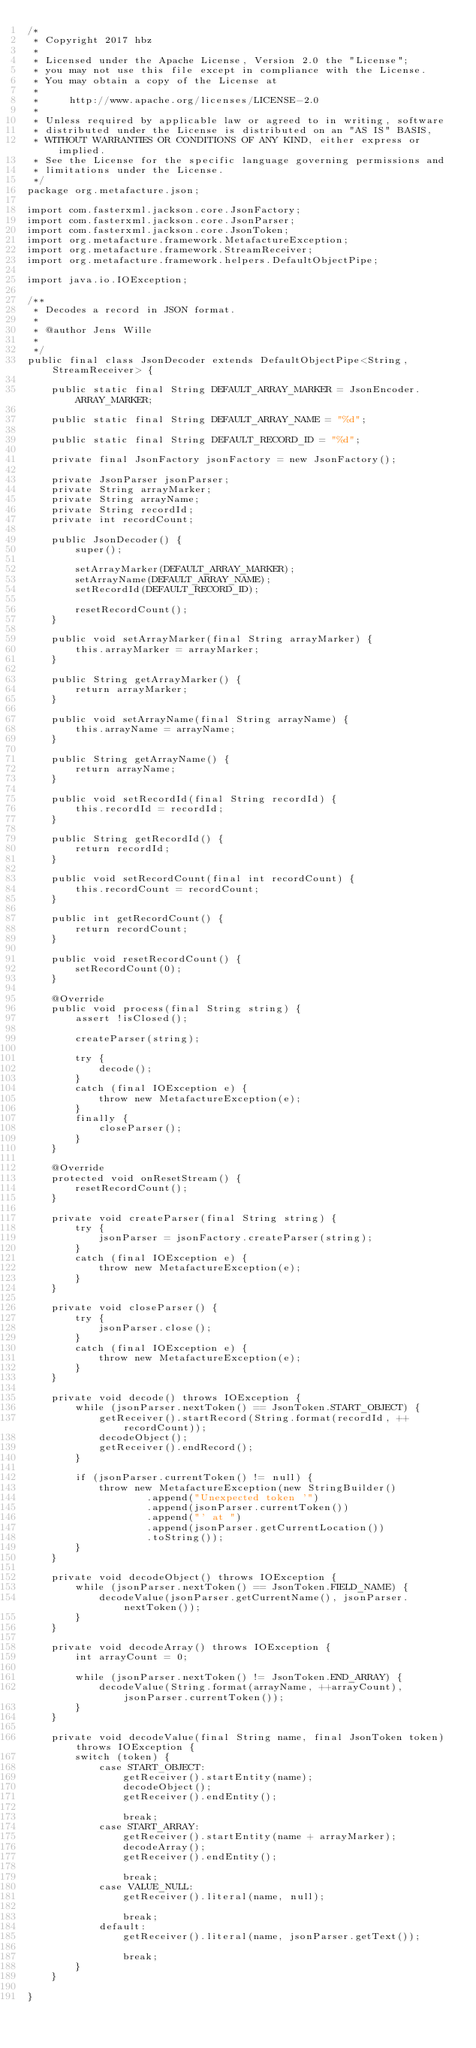<code> <loc_0><loc_0><loc_500><loc_500><_Java_>/*
 * Copyright 2017 hbz
 *
 * Licensed under the Apache License, Version 2.0 the "License";
 * you may not use this file except in compliance with the License.
 * You may obtain a copy of the License at
 *
 *     http://www.apache.org/licenses/LICENSE-2.0
 *
 * Unless required by applicable law or agreed to in writing, software
 * distributed under the License is distributed on an "AS IS" BASIS,
 * WITHOUT WARRANTIES OR CONDITIONS OF ANY KIND, either express or implied.
 * See the License for the specific language governing permissions and
 * limitations under the License.
 */
package org.metafacture.json;

import com.fasterxml.jackson.core.JsonFactory;
import com.fasterxml.jackson.core.JsonParser;
import com.fasterxml.jackson.core.JsonToken;
import org.metafacture.framework.MetafactureException;
import org.metafacture.framework.StreamReceiver;
import org.metafacture.framework.helpers.DefaultObjectPipe;

import java.io.IOException;

/**
 * Decodes a record in JSON format.
 *
 * @author Jens Wille
 *
 */
public final class JsonDecoder extends DefaultObjectPipe<String, StreamReceiver> {

    public static final String DEFAULT_ARRAY_MARKER = JsonEncoder.ARRAY_MARKER;

    public static final String DEFAULT_ARRAY_NAME = "%d";

    public static final String DEFAULT_RECORD_ID = "%d";

    private final JsonFactory jsonFactory = new JsonFactory();

    private JsonParser jsonParser;
    private String arrayMarker;
    private String arrayName;
    private String recordId;
    private int recordCount;

    public JsonDecoder() {
        super();

        setArrayMarker(DEFAULT_ARRAY_MARKER);
        setArrayName(DEFAULT_ARRAY_NAME);
        setRecordId(DEFAULT_RECORD_ID);

        resetRecordCount();
    }

    public void setArrayMarker(final String arrayMarker) {
        this.arrayMarker = arrayMarker;
    }

    public String getArrayMarker() {
        return arrayMarker;
    }

    public void setArrayName(final String arrayName) {
        this.arrayName = arrayName;
    }

    public String getArrayName() {
        return arrayName;
    }

    public void setRecordId(final String recordId) {
        this.recordId = recordId;
    }

    public String getRecordId() {
        return recordId;
    }

    public void setRecordCount(final int recordCount) {
        this.recordCount = recordCount;
    }

    public int getRecordCount() {
        return recordCount;
    }

    public void resetRecordCount() {
        setRecordCount(0);
    }

    @Override
    public void process(final String string) {
        assert !isClosed();

        createParser(string);

        try {
            decode();
        }
        catch (final IOException e) {
            throw new MetafactureException(e);
        }
        finally {
            closeParser();
        }
    }

    @Override
    protected void onResetStream() {
        resetRecordCount();
    }

    private void createParser(final String string) {
        try {
            jsonParser = jsonFactory.createParser(string);
        }
        catch (final IOException e) {
            throw new MetafactureException(e);
        }
    }

    private void closeParser() {
        try {
            jsonParser.close();
        }
        catch (final IOException e) {
            throw new MetafactureException(e);
        }
    }

    private void decode() throws IOException {
        while (jsonParser.nextToken() == JsonToken.START_OBJECT) {
            getReceiver().startRecord(String.format(recordId, ++recordCount));
            decodeObject();
            getReceiver().endRecord();
        }

        if (jsonParser.currentToken() != null) {
            throw new MetafactureException(new StringBuilder()
                    .append("Unexpected token '")
                    .append(jsonParser.currentToken())
                    .append("' at ")
                    .append(jsonParser.getCurrentLocation())
                    .toString());
        }
    }

    private void decodeObject() throws IOException {
        while (jsonParser.nextToken() == JsonToken.FIELD_NAME) {
            decodeValue(jsonParser.getCurrentName(), jsonParser.nextToken());
        }
    }

    private void decodeArray() throws IOException {
        int arrayCount = 0;

        while (jsonParser.nextToken() != JsonToken.END_ARRAY) {
            decodeValue(String.format(arrayName, ++arrayCount), jsonParser.currentToken());
        }
    }

    private void decodeValue(final String name, final JsonToken token) throws IOException {
        switch (token) {
            case START_OBJECT:
                getReceiver().startEntity(name);
                decodeObject();
                getReceiver().endEntity();

                break;
            case START_ARRAY:
                getReceiver().startEntity(name + arrayMarker);
                decodeArray();
                getReceiver().endEntity();

                break;
            case VALUE_NULL:
                getReceiver().literal(name, null);

                break;
            default:
                getReceiver().literal(name, jsonParser.getText());

                break;
        }
    }

}
</code> 